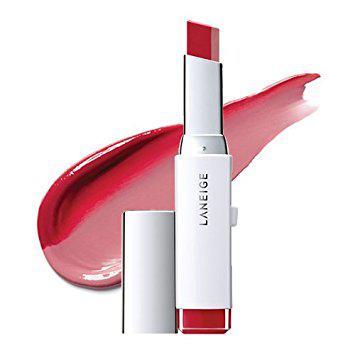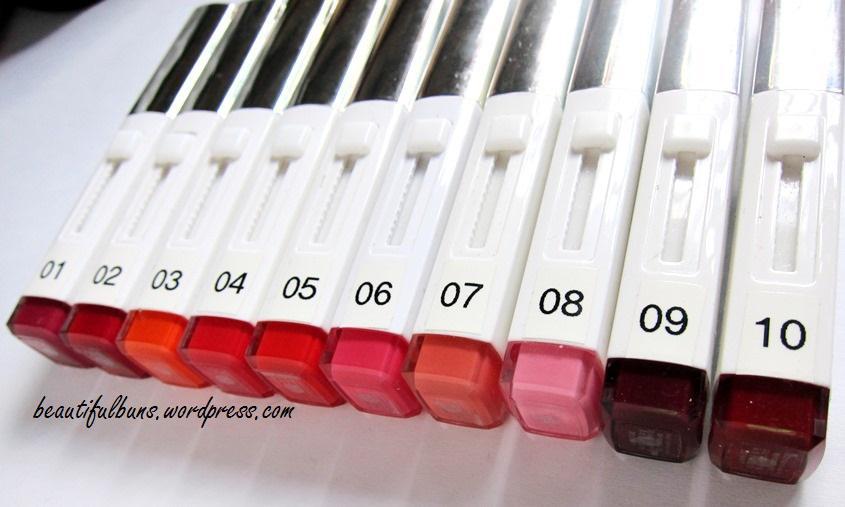The first image is the image on the left, the second image is the image on the right. Evaluate the accuracy of this statement regarding the images: "One image shows 5 or more tubes of lipstick, and the other shows how the colors look when applied to the lips.". Is it true? Answer yes or no. No. The first image is the image on the left, the second image is the image on the right. For the images displayed, is the sentence "An image shows a collage of at least ten painted pairs of lips." factually correct? Answer yes or no. No. 